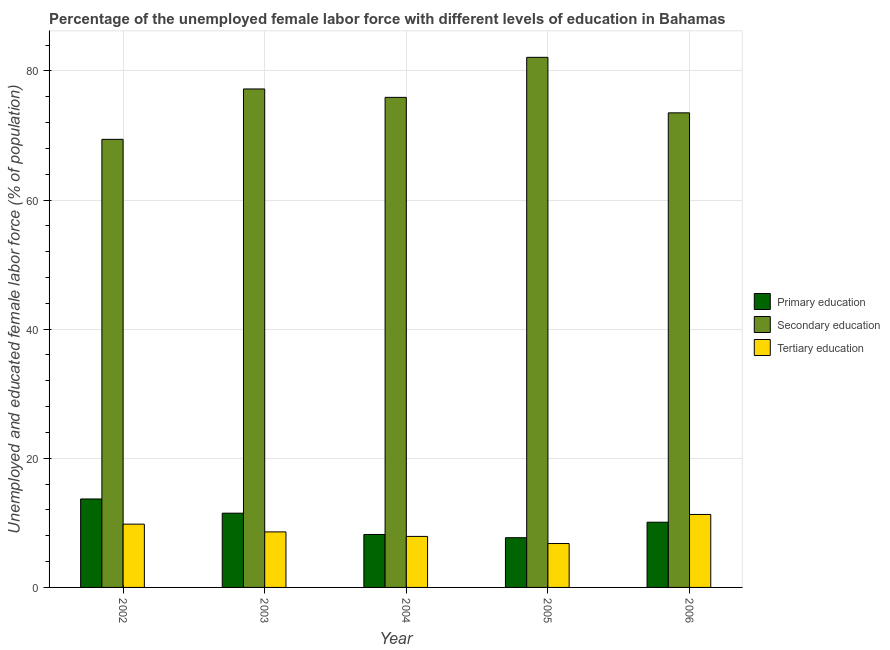How many groups of bars are there?
Your response must be concise. 5. Are the number of bars on each tick of the X-axis equal?
Give a very brief answer. Yes. What is the percentage of female labor force who received primary education in 2002?
Offer a terse response. 13.7. Across all years, what is the maximum percentage of female labor force who received primary education?
Your answer should be very brief. 13.7. Across all years, what is the minimum percentage of female labor force who received secondary education?
Provide a succinct answer. 69.4. What is the total percentage of female labor force who received tertiary education in the graph?
Offer a very short reply. 44.4. What is the difference between the percentage of female labor force who received tertiary education in 2003 and that in 2006?
Your answer should be compact. -2.7. What is the difference between the percentage of female labor force who received secondary education in 2002 and the percentage of female labor force who received primary education in 2005?
Keep it short and to the point. -12.7. What is the average percentage of female labor force who received primary education per year?
Provide a short and direct response. 10.24. What is the ratio of the percentage of female labor force who received primary education in 2002 to that in 2004?
Your answer should be very brief. 1.67. Is the percentage of female labor force who received primary education in 2003 less than that in 2005?
Ensure brevity in your answer.  No. Is the difference between the percentage of female labor force who received secondary education in 2004 and 2005 greater than the difference between the percentage of female labor force who received primary education in 2004 and 2005?
Offer a terse response. No. What is the difference between the highest and the second highest percentage of female labor force who received secondary education?
Your answer should be compact. 4.9. What is the difference between the highest and the lowest percentage of female labor force who received tertiary education?
Your response must be concise. 4.5. What does the 1st bar from the left in 2005 represents?
Offer a very short reply. Primary education. How many bars are there?
Make the answer very short. 15. How many years are there in the graph?
Keep it short and to the point. 5. What is the difference between two consecutive major ticks on the Y-axis?
Keep it short and to the point. 20. Does the graph contain any zero values?
Offer a very short reply. No. Does the graph contain grids?
Ensure brevity in your answer.  Yes. What is the title of the graph?
Provide a succinct answer. Percentage of the unemployed female labor force with different levels of education in Bahamas. Does "Coal" appear as one of the legend labels in the graph?
Give a very brief answer. No. What is the label or title of the X-axis?
Give a very brief answer. Year. What is the label or title of the Y-axis?
Your answer should be compact. Unemployed and educated female labor force (% of population). What is the Unemployed and educated female labor force (% of population) in Primary education in 2002?
Provide a succinct answer. 13.7. What is the Unemployed and educated female labor force (% of population) in Secondary education in 2002?
Your answer should be compact. 69.4. What is the Unemployed and educated female labor force (% of population) in Tertiary education in 2002?
Your response must be concise. 9.8. What is the Unemployed and educated female labor force (% of population) in Primary education in 2003?
Keep it short and to the point. 11.5. What is the Unemployed and educated female labor force (% of population) in Secondary education in 2003?
Make the answer very short. 77.2. What is the Unemployed and educated female labor force (% of population) of Tertiary education in 2003?
Your response must be concise. 8.6. What is the Unemployed and educated female labor force (% of population) in Primary education in 2004?
Make the answer very short. 8.2. What is the Unemployed and educated female labor force (% of population) of Secondary education in 2004?
Ensure brevity in your answer.  75.9. What is the Unemployed and educated female labor force (% of population) of Tertiary education in 2004?
Offer a terse response. 7.9. What is the Unemployed and educated female labor force (% of population) in Primary education in 2005?
Offer a terse response. 7.7. What is the Unemployed and educated female labor force (% of population) in Secondary education in 2005?
Keep it short and to the point. 82.1. What is the Unemployed and educated female labor force (% of population) in Tertiary education in 2005?
Offer a very short reply. 6.8. What is the Unemployed and educated female labor force (% of population) of Primary education in 2006?
Your answer should be compact. 10.1. What is the Unemployed and educated female labor force (% of population) of Secondary education in 2006?
Ensure brevity in your answer.  73.5. What is the Unemployed and educated female labor force (% of population) in Tertiary education in 2006?
Your response must be concise. 11.3. Across all years, what is the maximum Unemployed and educated female labor force (% of population) of Primary education?
Offer a terse response. 13.7. Across all years, what is the maximum Unemployed and educated female labor force (% of population) in Secondary education?
Keep it short and to the point. 82.1. Across all years, what is the maximum Unemployed and educated female labor force (% of population) in Tertiary education?
Make the answer very short. 11.3. Across all years, what is the minimum Unemployed and educated female labor force (% of population) of Primary education?
Your answer should be very brief. 7.7. Across all years, what is the minimum Unemployed and educated female labor force (% of population) in Secondary education?
Offer a very short reply. 69.4. Across all years, what is the minimum Unemployed and educated female labor force (% of population) of Tertiary education?
Provide a succinct answer. 6.8. What is the total Unemployed and educated female labor force (% of population) in Primary education in the graph?
Make the answer very short. 51.2. What is the total Unemployed and educated female labor force (% of population) in Secondary education in the graph?
Ensure brevity in your answer.  378.1. What is the total Unemployed and educated female labor force (% of population) of Tertiary education in the graph?
Ensure brevity in your answer.  44.4. What is the difference between the Unemployed and educated female labor force (% of population) in Tertiary education in 2002 and that in 2003?
Make the answer very short. 1.2. What is the difference between the Unemployed and educated female labor force (% of population) in Tertiary education in 2002 and that in 2004?
Ensure brevity in your answer.  1.9. What is the difference between the Unemployed and educated female labor force (% of population) of Secondary education in 2002 and that in 2005?
Keep it short and to the point. -12.7. What is the difference between the Unemployed and educated female labor force (% of population) of Tertiary education in 2002 and that in 2005?
Provide a succinct answer. 3. What is the difference between the Unemployed and educated female labor force (% of population) in Primary education in 2002 and that in 2006?
Provide a succinct answer. 3.6. What is the difference between the Unemployed and educated female labor force (% of population) in Primary education in 2003 and that in 2004?
Offer a terse response. 3.3. What is the difference between the Unemployed and educated female labor force (% of population) in Secondary education in 2003 and that in 2004?
Your answer should be compact. 1.3. What is the difference between the Unemployed and educated female labor force (% of population) in Secondary education in 2003 and that in 2005?
Your response must be concise. -4.9. What is the difference between the Unemployed and educated female labor force (% of population) in Tertiary education in 2003 and that in 2005?
Your answer should be compact. 1.8. What is the difference between the Unemployed and educated female labor force (% of population) in Primary education in 2003 and that in 2006?
Your answer should be very brief. 1.4. What is the difference between the Unemployed and educated female labor force (% of population) in Secondary education in 2003 and that in 2006?
Your response must be concise. 3.7. What is the difference between the Unemployed and educated female labor force (% of population) in Primary education in 2004 and that in 2005?
Your response must be concise. 0.5. What is the difference between the Unemployed and educated female labor force (% of population) of Secondary education in 2004 and that in 2005?
Offer a terse response. -6.2. What is the difference between the Unemployed and educated female labor force (% of population) of Tertiary education in 2005 and that in 2006?
Offer a very short reply. -4.5. What is the difference between the Unemployed and educated female labor force (% of population) in Primary education in 2002 and the Unemployed and educated female labor force (% of population) in Secondary education in 2003?
Keep it short and to the point. -63.5. What is the difference between the Unemployed and educated female labor force (% of population) in Secondary education in 2002 and the Unemployed and educated female labor force (% of population) in Tertiary education in 2003?
Provide a succinct answer. 60.8. What is the difference between the Unemployed and educated female labor force (% of population) in Primary education in 2002 and the Unemployed and educated female labor force (% of population) in Secondary education in 2004?
Offer a very short reply. -62.2. What is the difference between the Unemployed and educated female labor force (% of population) of Secondary education in 2002 and the Unemployed and educated female labor force (% of population) of Tertiary education in 2004?
Make the answer very short. 61.5. What is the difference between the Unemployed and educated female labor force (% of population) of Primary education in 2002 and the Unemployed and educated female labor force (% of population) of Secondary education in 2005?
Make the answer very short. -68.4. What is the difference between the Unemployed and educated female labor force (% of population) in Secondary education in 2002 and the Unemployed and educated female labor force (% of population) in Tertiary education in 2005?
Give a very brief answer. 62.6. What is the difference between the Unemployed and educated female labor force (% of population) in Primary education in 2002 and the Unemployed and educated female labor force (% of population) in Secondary education in 2006?
Provide a short and direct response. -59.8. What is the difference between the Unemployed and educated female labor force (% of population) in Secondary education in 2002 and the Unemployed and educated female labor force (% of population) in Tertiary education in 2006?
Give a very brief answer. 58.1. What is the difference between the Unemployed and educated female labor force (% of population) of Primary education in 2003 and the Unemployed and educated female labor force (% of population) of Secondary education in 2004?
Offer a terse response. -64.4. What is the difference between the Unemployed and educated female labor force (% of population) in Secondary education in 2003 and the Unemployed and educated female labor force (% of population) in Tertiary education in 2004?
Make the answer very short. 69.3. What is the difference between the Unemployed and educated female labor force (% of population) of Primary education in 2003 and the Unemployed and educated female labor force (% of population) of Secondary education in 2005?
Keep it short and to the point. -70.6. What is the difference between the Unemployed and educated female labor force (% of population) of Secondary education in 2003 and the Unemployed and educated female labor force (% of population) of Tertiary education in 2005?
Give a very brief answer. 70.4. What is the difference between the Unemployed and educated female labor force (% of population) of Primary education in 2003 and the Unemployed and educated female labor force (% of population) of Secondary education in 2006?
Keep it short and to the point. -62. What is the difference between the Unemployed and educated female labor force (% of population) in Primary education in 2003 and the Unemployed and educated female labor force (% of population) in Tertiary education in 2006?
Provide a succinct answer. 0.2. What is the difference between the Unemployed and educated female labor force (% of population) of Secondary education in 2003 and the Unemployed and educated female labor force (% of population) of Tertiary education in 2006?
Your answer should be compact. 65.9. What is the difference between the Unemployed and educated female labor force (% of population) of Primary education in 2004 and the Unemployed and educated female labor force (% of population) of Secondary education in 2005?
Ensure brevity in your answer.  -73.9. What is the difference between the Unemployed and educated female labor force (% of population) in Primary education in 2004 and the Unemployed and educated female labor force (% of population) in Tertiary education in 2005?
Offer a very short reply. 1.4. What is the difference between the Unemployed and educated female labor force (% of population) in Secondary education in 2004 and the Unemployed and educated female labor force (% of population) in Tertiary education in 2005?
Ensure brevity in your answer.  69.1. What is the difference between the Unemployed and educated female labor force (% of population) of Primary education in 2004 and the Unemployed and educated female labor force (% of population) of Secondary education in 2006?
Your answer should be very brief. -65.3. What is the difference between the Unemployed and educated female labor force (% of population) of Primary education in 2004 and the Unemployed and educated female labor force (% of population) of Tertiary education in 2006?
Make the answer very short. -3.1. What is the difference between the Unemployed and educated female labor force (% of population) in Secondary education in 2004 and the Unemployed and educated female labor force (% of population) in Tertiary education in 2006?
Provide a short and direct response. 64.6. What is the difference between the Unemployed and educated female labor force (% of population) of Primary education in 2005 and the Unemployed and educated female labor force (% of population) of Secondary education in 2006?
Your answer should be very brief. -65.8. What is the difference between the Unemployed and educated female labor force (% of population) in Secondary education in 2005 and the Unemployed and educated female labor force (% of population) in Tertiary education in 2006?
Keep it short and to the point. 70.8. What is the average Unemployed and educated female labor force (% of population) in Primary education per year?
Your answer should be compact. 10.24. What is the average Unemployed and educated female labor force (% of population) of Secondary education per year?
Ensure brevity in your answer.  75.62. What is the average Unemployed and educated female labor force (% of population) in Tertiary education per year?
Give a very brief answer. 8.88. In the year 2002, what is the difference between the Unemployed and educated female labor force (% of population) of Primary education and Unemployed and educated female labor force (% of population) of Secondary education?
Your response must be concise. -55.7. In the year 2002, what is the difference between the Unemployed and educated female labor force (% of population) in Secondary education and Unemployed and educated female labor force (% of population) in Tertiary education?
Give a very brief answer. 59.6. In the year 2003, what is the difference between the Unemployed and educated female labor force (% of population) in Primary education and Unemployed and educated female labor force (% of population) in Secondary education?
Provide a succinct answer. -65.7. In the year 2003, what is the difference between the Unemployed and educated female labor force (% of population) in Primary education and Unemployed and educated female labor force (% of population) in Tertiary education?
Your answer should be very brief. 2.9. In the year 2003, what is the difference between the Unemployed and educated female labor force (% of population) of Secondary education and Unemployed and educated female labor force (% of population) of Tertiary education?
Your answer should be very brief. 68.6. In the year 2004, what is the difference between the Unemployed and educated female labor force (% of population) in Primary education and Unemployed and educated female labor force (% of population) in Secondary education?
Your answer should be compact. -67.7. In the year 2005, what is the difference between the Unemployed and educated female labor force (% of population) of Primary education and Unemployed and educated female labor force (% of population) of Secondary education?
Keep it short and to the point. -74.4. In the year 2005, what is the difference between the Unemployed and educated female labor force (% of population) in Primary education and Unemployed and educated female labor force (% of population) in Tertiary education?
Make the answer very short. 0.9. In the year 2005, what is the difference between the Unemployed and educated female labor force (% of population) in Secondary education and Unemployed and educated female labor force (% of population) in Tertiary education?
Provide a succinct answer. 75.3. In the year 2006, what is the difference between the Unemployed and educated female labor force (% of population) of Primary education and Unemployed and educated female labor force (% of population) of Secondary education?
Your answer should be compact. -63.4. In the year 2006, what is the difference between the Unemployed and educated female labor force (% of population) of Secondary education and Unemployed and educated female labor force (% of population) of Tertiary education?
Provide a short and direct response. 62.2. What is the ratio of the Unemployed and educated female labor force (% of population) of Primary education in 2002 to that in 2003?
Offer a very short reply. 1.19. What is the ratio of the Unemployed and educated female labor force (% of population) of Secondary education in 2002 to that in 2003?
Offer a terse response. 0.9. What is the ratio of the Unemployed and educated female labor force (% of population) of Tertiary education in 2002 to that in 2003?
Provide a succinct answer. 1.14. What is the ratio of the Unemployed and educated female labor force (% of population) in Primary education in 2002 to that in 2004?
Offer a terse response. 1.67. What is the ratio of the Unemployed and educated female labor force (% of population) in Secondary education in 2002 to that in 2004?
Make the answer very short. 0.91. What is the ratio of the Unemployed and educated female labor force (% of population) in Tertiary education in 2002 to that in 2004?
Your answer should be very brief. 1.24. What is the ratio of the Unemployed and educated female labor force (% of population) in Primary education in 2002 to that in 2005?
Offer a very short reply. 1.78. What is the ratio of the Unemployed and educated female labor force (% of population) in Secondary education in 2002 to that in 2005?
Give a very brief answer. 0.85. What is the ratio of the Unemployed and educated female labor force (% of population) of Tertiary education in 2002 to that in 2005?
Your response must be concise. 1.44. What is the ratio of the Unemployed and educated female labor force (% of population) of Primary education in 2002 to that in 2006?
Keep it short and to the point. 1.36. What is the ratio of the Unemployed and educated female labor force (% of population) in Secondary education in 2002 to that in 2006?
Provide a short and direct response. 0.94. What is the ratio of the Unemployed and educated female labor force (% of population) in Tertiary education in 2002 to that in 2006?
Keep it short and to the point. 0.87. What is the ratio of the Unemployed and educated female labor force (% of population) of Primary education in 2003 to that in 2004?
Your answer should be very brief. 1.4. What is the ratio of the Unemployed and educated female labor force (% of population) of Secondary education in 2003 to that in 2004?
Ensure brevity in your answer.  1.02. What is the ratio of the Unemployed and educated female labor force (% of population) of Tertiary education in 2003 to that in 2004?
Your answer should be very brief. 1.09. What is the ratio of the Unemployed and educated female labor force (% of population) in Primary education in 2003 to that in 2005?
Offer a very short reply. 1.49. What is the ratio of the Unemployed and educated female labor force (% of population) of Secondary education in 2003 to that in 2005?
Your response must be concise. 0.94. What is the ratio of the Unemployed and educated female labor force (% of population) in Tertiary education in 2003 to that in 2005?
Give a very brief answer. 1.26. What is the ratio of the Unemployed and educated female labor force (% of population) in Primary education in 2003 to that in 2006?
Provide a succinct answer. 1.14. What is the ratio of the Unemployed and educated female labor force (% of population) of Secondary education in 2003 to that in 2006?
Make the answer very short. 1.05. What is the ratio of the Unemployed and educated female labor force (% of population) of Tertiary education in 2003 to that in 2006?
Offer a terse response. 0.76. What is the ratio of the Unemployed and educated female labor force (% of population) in Primary education in 2004 to that in 2005?
Provide a short and direct response. 1.06. What is the ratio of the Unemployed and educated female labor force (% of population) in Secondary education in 2004 to that in 2005?
Give a very brief answer. 0.92. What is the ratio of the Unemployed and educated female labor force (% of population) of Tertiary education in 2004 to that in 2005?
Ensure brevity in your answer.  1.16. What is the ratio of the Unemployed and educated female labor force (% of population) in Primary education in 2004 to that in 2006?
Offer a very short reply. 0.81. What is the ratio of the Unemployed and educated female labor force (% of population) in Secondary education in 2004 to that in 2006?
Your answer should be very brief. 1.03. What is the ratio of the Unemployed and educated female labor force (% of population) in Tertiary education in 2004 to that in 2006?
Your answer should be compact. 0.7. What is the ratio of the Unemployed and educated female labor force (% of population) of Primary education in 2005 to that in 2006?
Your response must be concise. 0.76. What is the ratio of the Unemployed and educated female labor force (% of population) in Secondary education in 2005 to that in 2006?
Offer a terse response. 1.12. What is the ratio of the Unemployed and educated female labor force (% of population) in Tertiary education in 2005 to that in 2006?
Your answer should be compact. 0.6. What is the difference between the highest and the second highest Unemployed and educated female labor force (% of population) of Secondary education?
Make the answer very short. 4.9. What is the difference between the highest and the second highest Unemployed and educated female labor force (% of population) of Tertiary education?
Keep it short and to the point. 1.5. What is the difference between the highest and the lowest Unemployed and educated female labor force (% of population) in Primary education?
Keep it short and to the point. 6. 